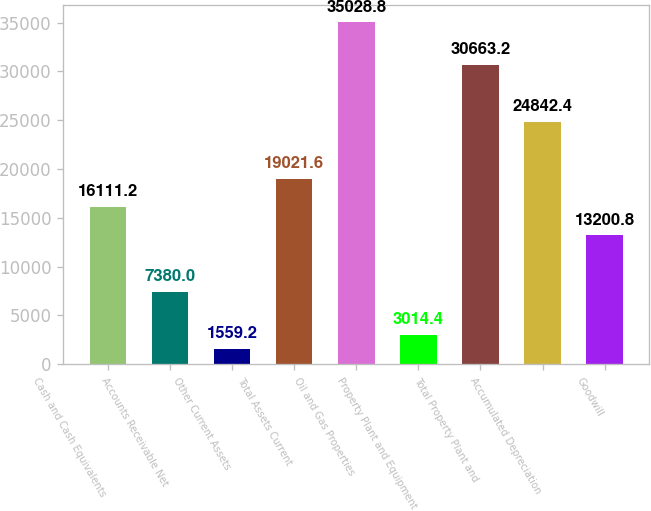Convert chart to OTSL. <chart><loc_0><loc_0><loc_500><loc_500><bar_chart><fcel>Cash and Cash Equivalents<fcel>Accounts Receivable Net<fcel>Other Current Assets<fcel>Total Assets Current<fcel>Oil and Gas Properties<fcel>Property Plant and Equipment<fcel>Total Property Plant and<fcel>Accumulated Depreciation<fcel>Goodwill<nl><fcel>16111.2<fcel>7380<fcel>1559.2<fcel>19021.6<fcel>35028.8<fcel>3014.4<fcel>30663.2<fcel>24842.4<fcel>13200.8<nl></chart> 